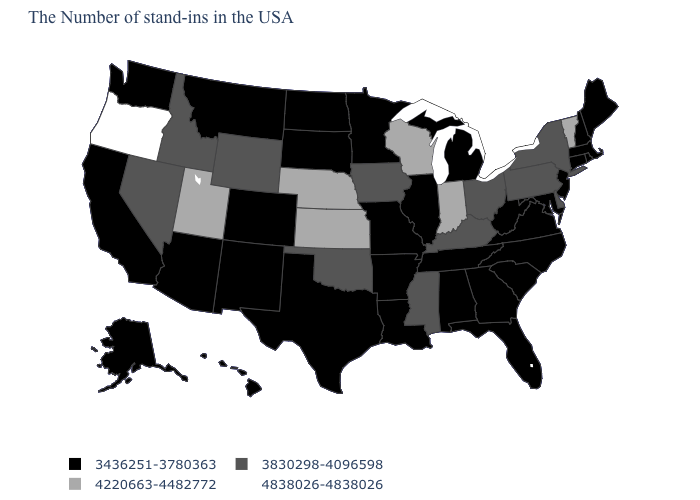Name the states that have a value in the range 4838026-4838026?
Be succinct. Oregon. Name the states that have a value in the range 3830298-4096598?
Short answer required. New York, Delaware, Pennsylvania, Ohio, Kentucky, Mississippi, Iowa, Oklahoma, Wyoming, Idaho, Nevada. What is the value of New Hampshire?
Short answer required. 3436251-3780363. What is the value of Tennessee?
Answer briefly. 3436251-3780363. What is the highest value in states that border Minnesota?
Short answer required. 4220663-4482772. Name the states that have a value in the range 3436251-3780363?
Keep it brief. Maine, Massachusetts, Rhode Island, New Hampshire, Connecticut, New Jersey, Maryland, Virginia, North Carolina, South Carolina, West Virginia, Florida, Georgia, Michigan, Alabama, Tennessee, Illinois, Louisiana, Missouri, Arkansas, Minnesota, Texas, South Dakota, North Dakota, Colorado, New Mexico, Montana, Arizona, California, Washington, Alaska, Hawaii. Does the first symbol in the legend represent the smallest category?
Give a very brief answer. Yes. What is the highest value in states that border Massachusetts?
Keep it brief. 4220663-4482772. What is the highest value in states that border Oklahoma?
Give a very brief answer. 4220663-4482772. Name the states that have a value in the range 4220663-4482772?
Be succinct. Vermont, Indiana, Wisconsin, Kansas, Nebraska, Utah. What is the value of Washington?
Short answer required. 3436251-3780363. Which states have the lowest value in the West?
Write a very short answer. Colorado, New Mexico, Montana, Arizona, California, Washington, Alaska, Hawaii. What is the lowest value in the West?
Write a very short answer. 3436251-3780363. Does North Dakota have a higher value than Rhode Island?
Write a very short answer. No. What is the highest value in states that border Virginia?
Concise answer only. 3830298-4096598. 